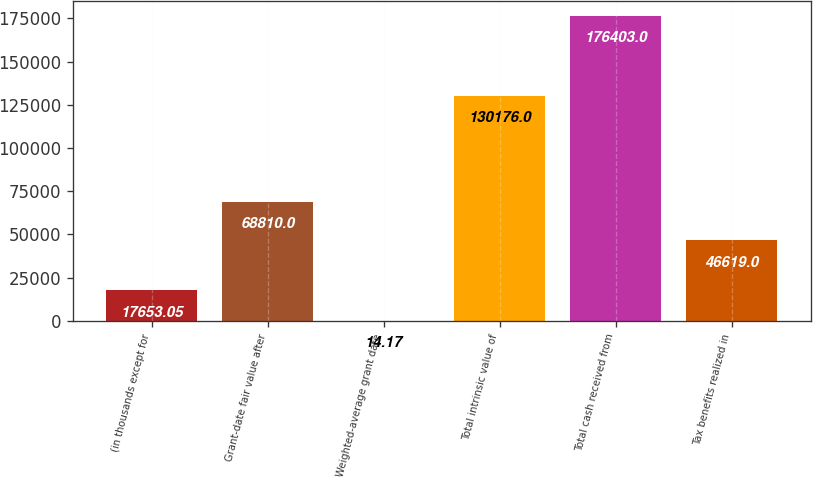<chart> <loc_0><loc_0><loc_500><loc_500><bar_chart><fcel>(in thousands except for<fcel>Grant-date fair value after<fcel>Weighted-average grant date<fcel>Total intrinsic value of<fcel>Total cash received from<fcel>Tax benefits realized in<nl><fcel>17653<fcel>68810<fcel>14.17<fcel>130176<fcel>176403<fcel>46619<nl></chart> 